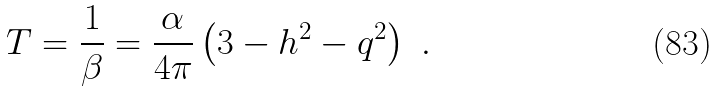<formula> <loc_0><loc_0><loc_500><loc_500>T = \frac { 1 } { \beta } = \frac { \alpha } { 4 \pi } \left ( 3 - h ^ { 2 } - q ^ { 2 } \right ) \ .</formula> 